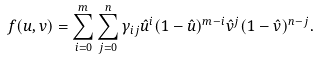<formula> <loc_0><loc_0><loc_500><loc_500>f ( u , v ) = \sum _ { i = 0 } ^ { m } \sum _ { j = 0 } ^ { n } \gamma _ { i j } \hat { u } ^ { i } ( 1 - \hat { u } ) ^ { m - i } \hat { v } ^ { j } ( 1 - \hat { v } ) ^ { n - j } .</formula> 